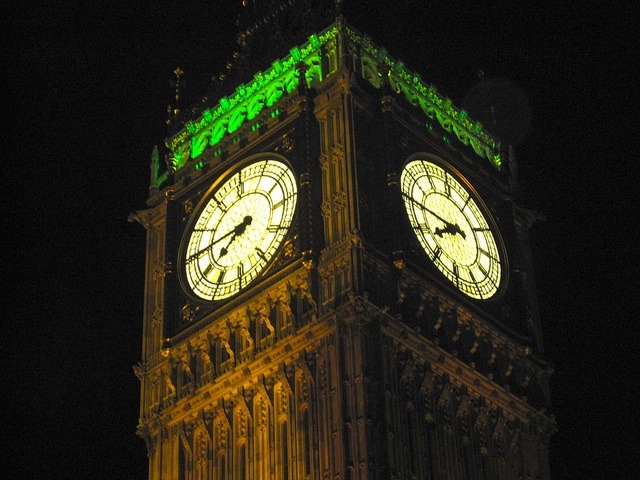Describe the objects in this image and their specific colors. I can see clock in black, ivory, and khaki tones and clock in black, beige, and khaki tones in this image. 